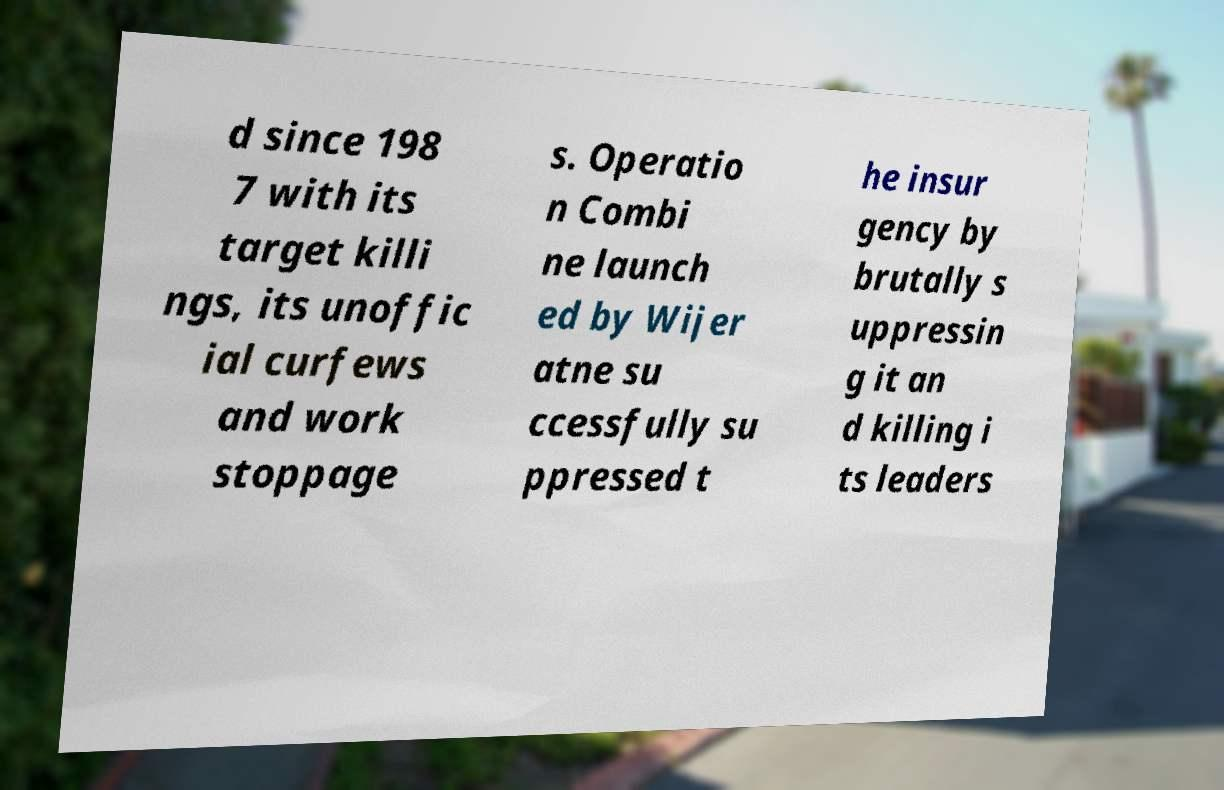For documentation purposes, I need the text within this image transcribed. Could you provide that? d since 198 7 with its target killi ngs, its unoffic ial curfews and work stoppage s. Operatio n Combi ne launch ed by Wijer atne su ccessfully su ppressed t he insur gency by brutally s uppressin g it an d killing i ts leaders 